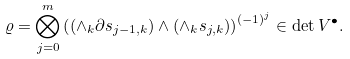<formula> <loc_0><loc_0><loc_500><loc_500>\varrho = \bigotimes _ { j = 0 } ^ { m } \left ( ( \wedge _ { k } \partial s _ { j - 1 , k } ) \wedge ( \wedge _ { k } s _ { j , k } ) \right ) ^ { ( - 1 ) ^ { j } } \in \det V ^ { \bullet } .</formula> 